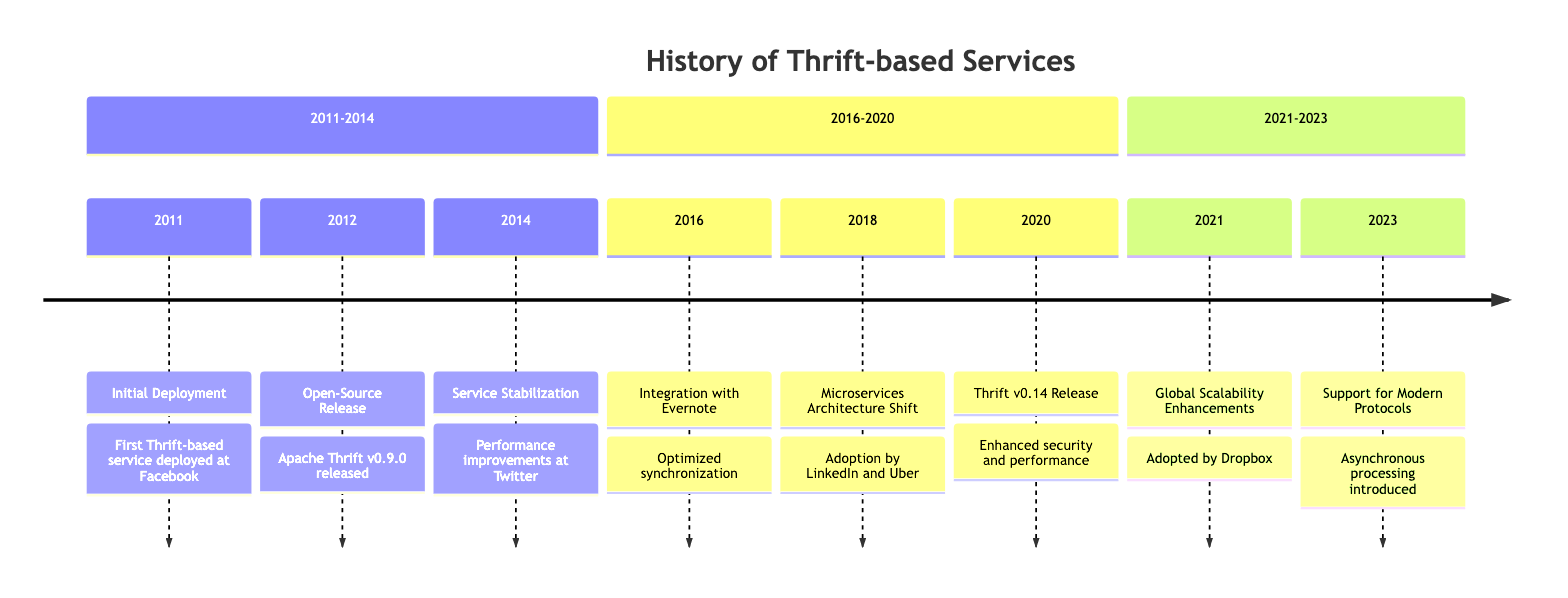What year was the Initial Deployment of Thrift? The event "Initial Deployment" occurs in the year 2011 on the timeline.
Answer: 2011 Which company first deployed a Thrift-based service? The description for "Initial Deployment" states it was deployed at Facebook.
Answer: Facebook What significant event happened in 2016? The timeline states that in 2016, the event was "Integration with Evernote."
Answer: Integration with Evernote How many significant events are listed between 2011 and 2014? Counting the events listed, we have three events: Initial Deployment, Open-Source Release, and Service Stabilization.
Answer: 3 Which two companies are mentioned as adopting Thrift in 2018? The description for the event "Microservices Architecture Shift" lists LinkedIn and Uber as organizations that started leveraging Thrift.
Answer: LinkedIn and Uber What was the version released in 2020? The event in 2020 states "Thrift v0.14 Release."
Answer: v0.14 What major improvements were made in 2021? The timeline mentions "Global Scalability Enhancements" as the key improvements introduced in 2021.
Answer: Global Scalability Enhancements What is the last significant improvement mentioned in the timeline? The final event in 2023 indicates the support for modern protocols and asynchronous processing as the last significant improvement.
Answer: Support for Modern Protocols How many total events are represented in the timeline? Upon counting the listed events, there are eight significant events shown in the timeline.
Answer: 8 